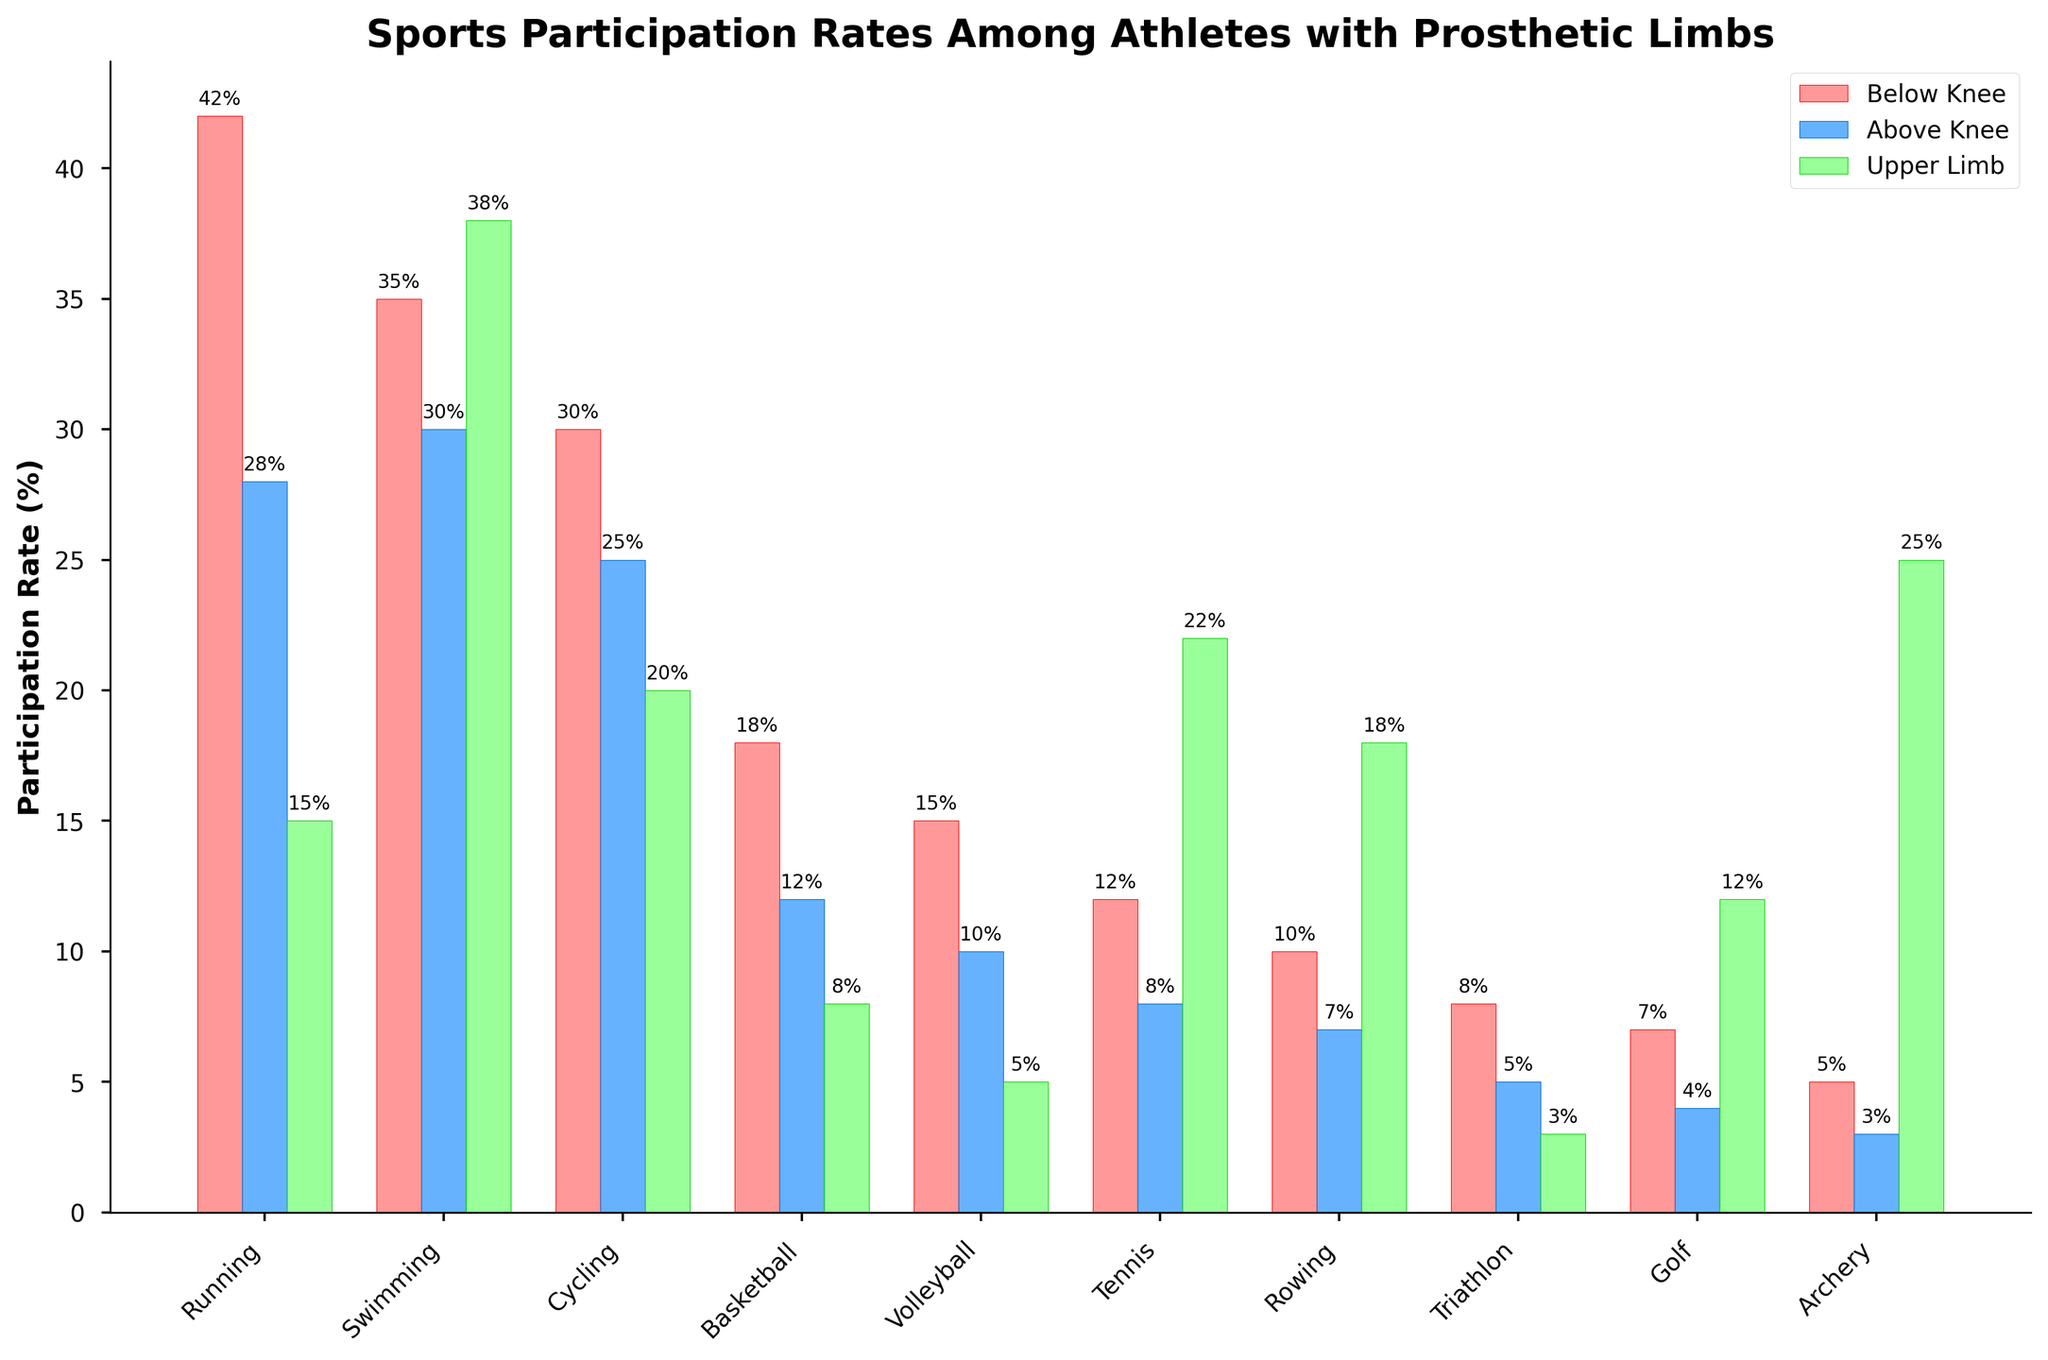Which sport has the highest participation rate among athletes with below knee prosthetic limbs? By examining the height of the red bars for all sports, we see that "Running" has the highest participation rate at 42%.
Answer: Running What is the difference in participation rates between below knee and upper limb athletes for Tennis? The red bar (below knee) for Tennis shows a value of 12%, whereas the green bar (upper limb) shows a value of 22%. The difference is 22% - 12% = 10%.
Answer: 10% Which sport shows the smallest participation rate among athletes with upper limb prosthetic limbs? By looking at all the green bars, we see that "Triathlon" has the smallest participation rate with a value of 3%.
Answer: Triathlon What is the total participation rate for Basketball across all prosthetic limb types? The individual participation rates for Basketball are: below knee (18%), above knee (12%), and upper limb (8%). Summing them gives us 18% + 12% + 8% = 38%.
Answer: 38% Compare the participation rates for Archery and Cycling among athletes with above-knee prosthetic limbs. Which sport has a higher rate? The blue bars show that the participation rate for Archery is 3% while for Cycling it is 25%. Therefore, Cycling has a higher participation rate.
Answer: Cycling What is the average participation rate for Swimming among all prosthetic limb groups? The participation rates for Swimming are: below knee (35%), above knee (30%), and upper limb (38%). The average is calculated as (35 + 30 + 38) / 3 = 103 / 3 ≈ 34.33%.
Answer: 34.33% Which sport has the most even distribution of participation rates across all prosthetic limb types? By visually comparing the height of the red, blue, and green bars, Swimming shows the most even distribution with participation rates (35%, 30%, and 38%), as the bars are of similar heights.
Answer: Swimming For the sport of Volleyball, how much greater is the below knee participation rate compared to the above knee rate? The red bar for Volleyball is 15% and the blue bar is 10%. The difference is 15% - 10% = 5%.
Answer: 5% What is the combined participation rate for below knee athletes in Running, Swimming, and Cycling? The individual participation rates for below knee athletes in these sports are: Running (42%), Swimming (35%), and Cycling (30%). Summing them gives 42% + 35% + 30% = 107%.
Answer: 107% Which sport has the lowest participation rate for the below knee group and what is the value? By comparing all the red bars, Archery has the lowest rate with a value of 5%.
Answer: Archery, 5% 